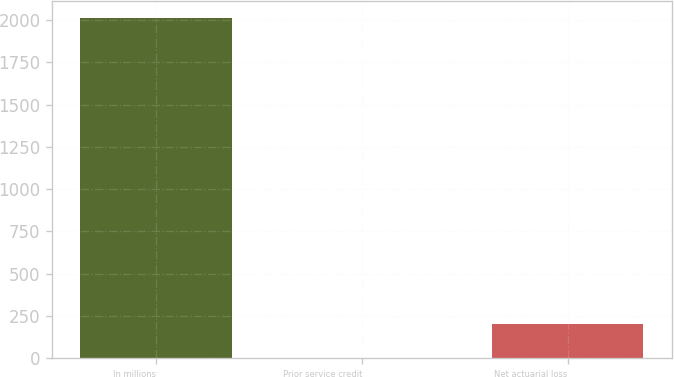Convert chart to OTSL. <chart><loc_0><loc_0><loc_500><loc_500><bar_chart><fcel>In millions<fcel>Prior service credit<fcel>Net actuarial loss<nl><fcel>2013<fcel>1<fcel>202.2<nl></chart> 